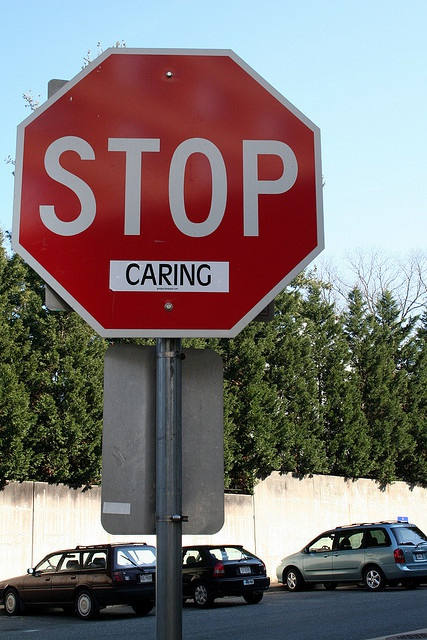Describe the objects in this image and their specific colors. I can see stop sign in lightblue, maroon, brown, darkgray, and black tones, car in lightblue, black, gray, ivory, and maroon tones, car in lightblue, black, gray, darkgray, and blue tones, and car in lightblue, black, ivory, gray, and navy tones in this image. 